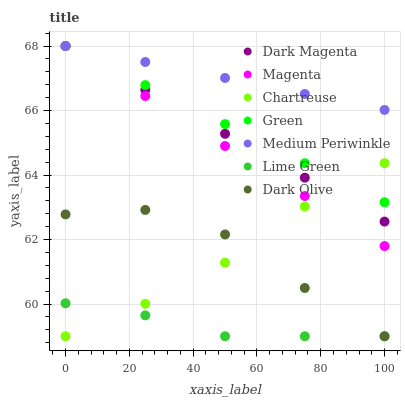Does Lime Green have the minimum area under the curve?
Answer yes or no. Yes. Does Medium Periwinkle have the maximum area under the curve?
Answer yes or no. Yes. Does Dark Olive have the minimum area under the curve?
Answer yes or no. No. Does Dark Olive have the maximum area under the curve?
Answer yes or no. No. Is Medium Periwinkle the smoothest?
Answer yes or no. Yes. Is Dark Olive the roughest?
Answer yes or no. Yes. Is Dark Olive the smoothest?
Answer yes or no. No. Is Medium Periwinkle the roughest?
Answer yes or no. No. Does Dark Olive have the lowest value?
Answer yes or no. Yes. Does Medium Periwinkle have the lowest value?
Answer yes or no. No. Does Magenta have the highest value?
Answer yes or no. Yes. Does Dark Olive have the highest value?
Answer yes or no. No. Is Lime Green less than Green?
Answer yes or no. Yes. Is Medium Periwinkle greater than Chartreuse?
Answer yes or no. Yes. Does Magenta intersect Dark Magenta?
Answer yes or no. Yes. Is Magenta less than Dark Magenta?
Answer yes or no. No. Is Magenta greater than Dark Magenta?
Answer yes or no. No. Does Lime Green intersect Green?
Answer yes or no. No. 